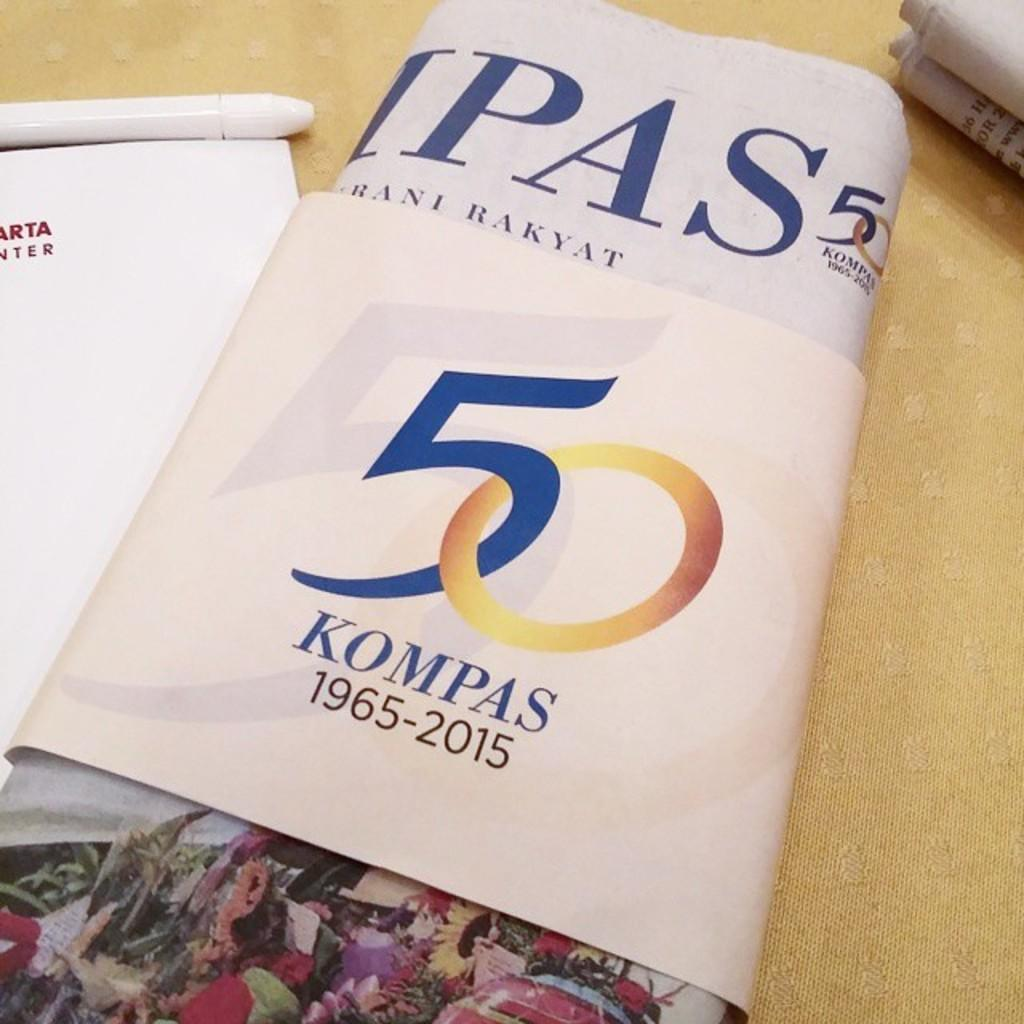<image>
Write a terse but informative summary of the picture. Pictured is a 50 year celebration, 1965-2015, notice titles Kompas. 